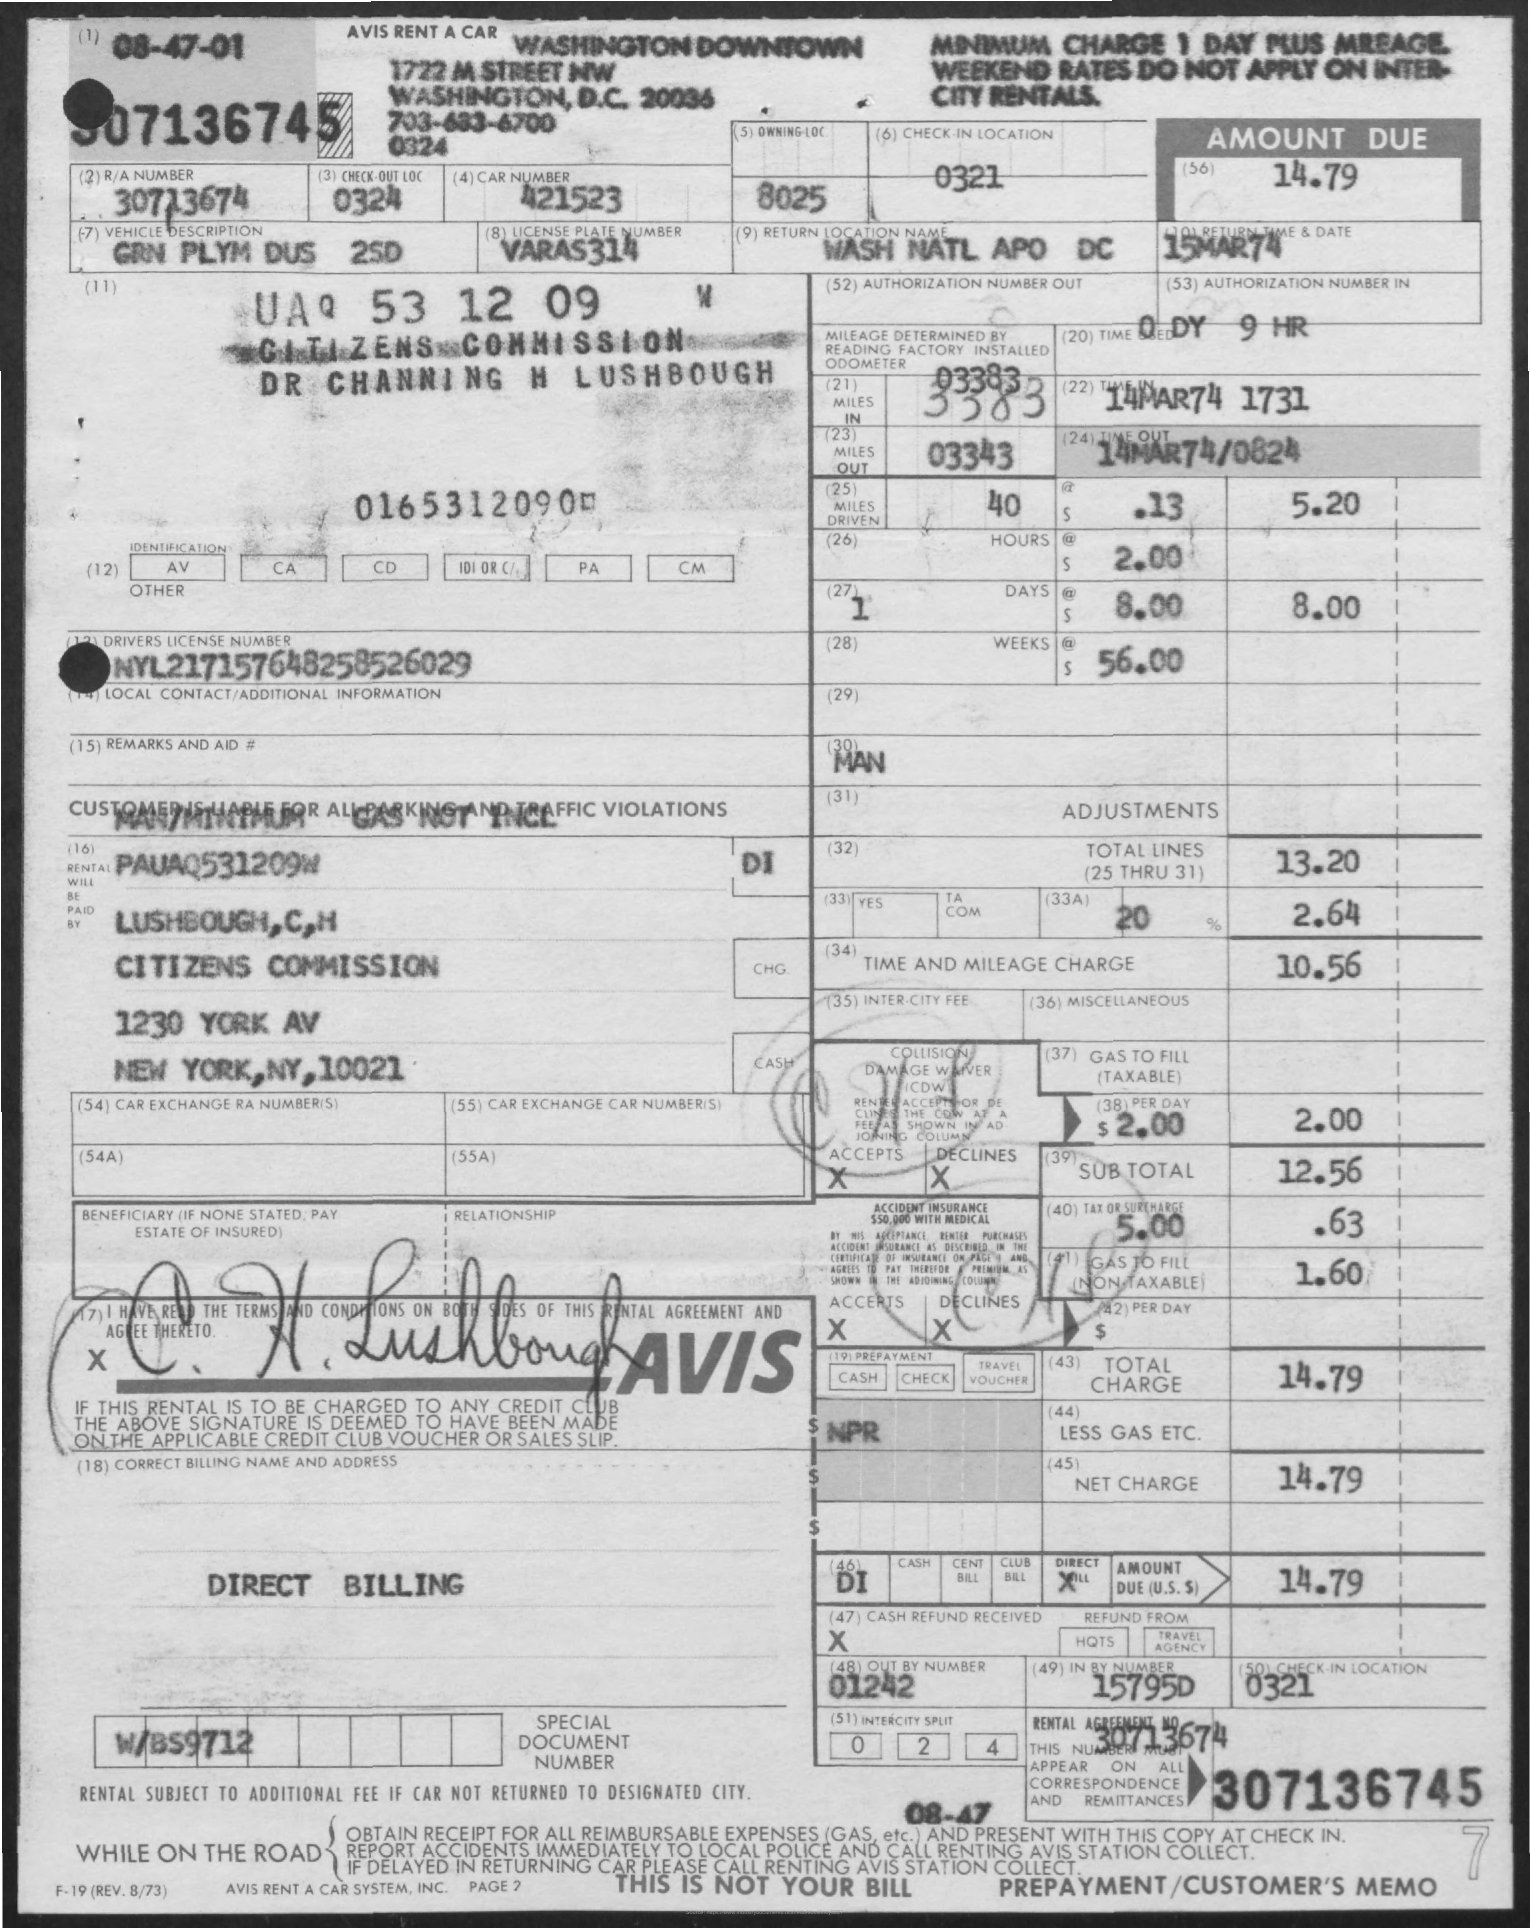What kind of car was rented according to this document? The document doesn't explicitly state the make and model of the car rented, but it mentions a 'GM Plym,' which might be an abbreviation for a General Motors Plymouth model. 